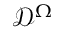Convert formula to latex. <formula><loc_0><loc_0><loc_500><loc_500>\mathcal { D } ^ { \Omega }</formula> 